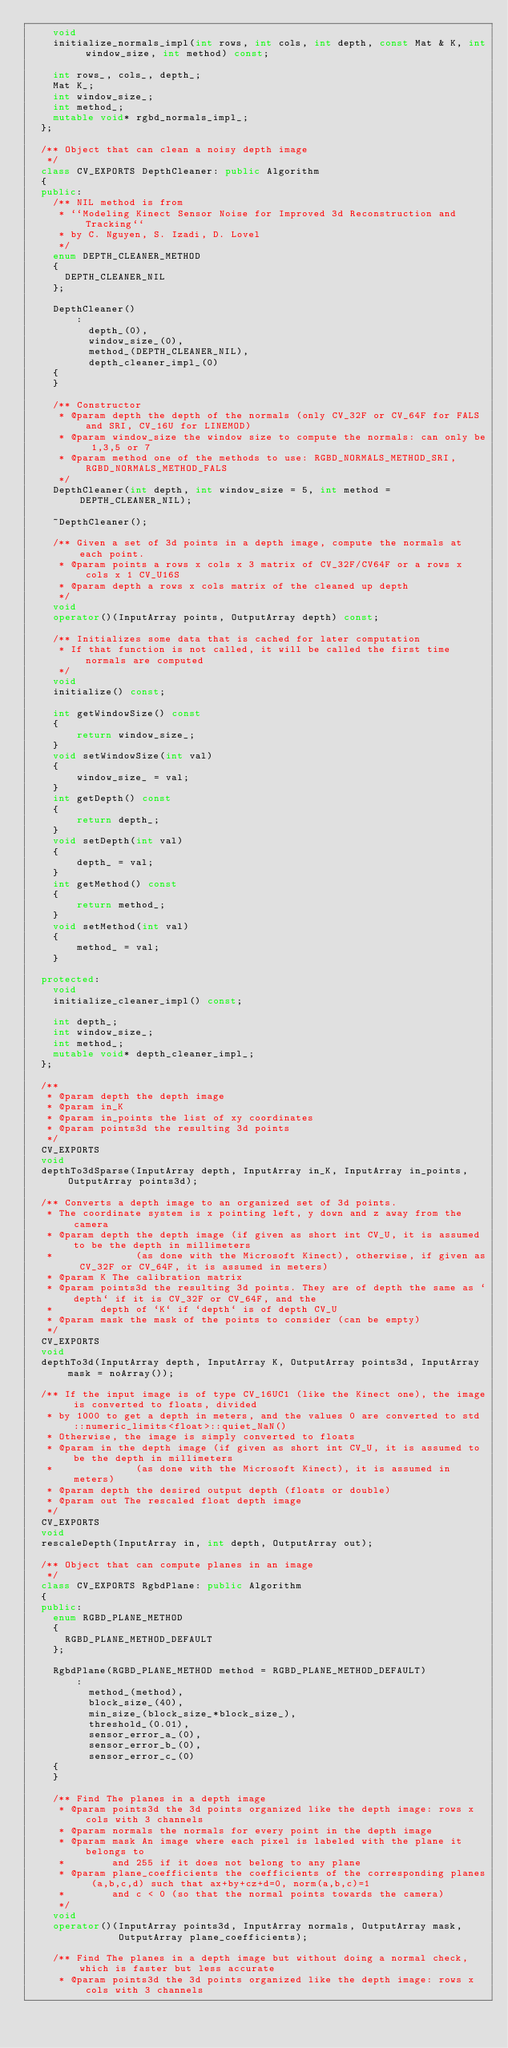Convert code to text. <code><loc_0><loc_0><loc_500><loc_500><_C++_>    void
    initialize_normals_impl(int rows, int cols, int depth, const Mat & K, int window_size, int method) const;

    int rows_, cols_, depth_;
    Mat K_;
    int window_size_;
    int method_;
    mutable void* rgbd_normals_impl_;
  };

  /** Object that can clean a noisy depth image
   */
  class CV_EXPORTS DepthCleaner: public Algorithm
  {
  public:
    /** NIL method is from
     * ``Modeling Kinect Sensor Noise for Improved 3d Reconstruction and Tracking``
     * by C. Nguyen, S. Izadi, D. Lovel
     */
    enum DEPTH_CLEANER_METHOD
    {
      DEPTH_CLEANER_NIL
    };

    DepthCleaner()
        :
          depth_(0),
          window_size_(0),
          method_(DEPTH_CLEANER_NIL),
          depth_cleaner_impl_(0)
    {
    }

    /** Constructor
     * @param depth the depth of the normals (only CV_32F or CV_64F for FALS and SRI, CV_16U for LINEMOD)
     * @param window_size the window size to compute the normals: can only be 1,3,5 or 7
     * @param method one of the methods to use: RGBD_NORMALS_METHOD_SRI, RGBD_NORMALS_METHOD_FALS
     */
    DepthCleaner(int depth, int window_size = 5, int method = DEPTH_CLEANER_NIL);

    ~DepthCleaner();

    /** Given a set of 3d points in a depth image, compute the normals at each point.
     * @param points a rows x cols x 3 matrix of CV_32F/CV64F or a rows x cols x 1 CV_U16S
     * @param depth a rows x cols matrix of the cleaned up depth
     */
    void
    operator()(InputArray points, OutputArray depth) const;

    /** Initializes some data that is cached for later computation
     * If that function is not called, it will be called the first time normals are computed
     */
    void
    initialize() const;

    int getWindowSize() const
    {
        return window_size_;
    }
    void setWindowSize(int val)
    {
        window_size_ = val;
    }
    int getDepth() const
    {
        return depth_;
    }
    void setDepth(int val)
    {
        depth_ = val;
    }
    int getMethod() const
    {
        return method_;
    }
    void setMethod(int val)
    {
        method_ = val;
    }

  protected:
    void
    initialize_cleaner_impl() const;

    int depth_;
    int window_size_;
    int method_;
    mutable void* depth_cleaner_impl_;
  };

  /**
   * @param depth the depth image
   * @param in_K
   * @param in_points the list of xy coordinates
   * @param points3d the resulting 3d points
   */
  CV_EXPORTS
  void
  depthTo3dSparse(InputArray depth, InputArray in_K, InputArray in_points, OutputArray points3d);

  /** Converts a depth image to an organized set of 3d points.
   * The coordinate system is x pointing left, y down and z away from the camera
   * @param depth the depth image (if given as short int CV_U, it is assumed to be the depth in millimeters
   *              (as done with the Microsoft Kinect), otherwise, if given as CV_32F or CV_64F, it is assumed in meters)
   * @param K The calibration matrix
   * @param points3d the resulting 3d points. They are of depth the same as `depth` if it is CV_32F or CV_64F, and the
   *        depth of `K` if `depth` is of depth CV_U
   * @param mask the mask of the points to consider (can be empty)
   */
  CV_EXPORTS
  void
  depthTo3d(InputArray depth, InputArray K, OutputArray points3d, InputArray mask = noArray());

  /** If the input image is of type CV_16UC1 (like the Kinect one), the image is converted to floats, divided
   * by 1000 to get a depth in meters, and the values 0 are converted to std::numeric_limits<float>::quiet_NaN()
   * Otherwise, the image is simply converted to floats
   * @param in the depth image (if given as short int CV_U, it is assumed to be the depth in millimeters
   *              (as done with the Microsoft Kinect), it is assumed in meters)
   * @param depth the desired output depth (floats or double)
   * @param out The rescaled float depth image
   */
  CV_EXPORTS
  void
  rescaleDepth(InputArray in, int depth, OutputArray out);

  /** Object that can compute planes in an image
   */
  class CV_EXPORTS RgbdPlane: public Algorithm
  {
  public:
    enum RGBD_PLANE_METHOD
    {
      RGBD_PLANE_METHOD_DEFAULT
    };

    RgbdPlane(RGBD_PLANE_METHOD method = RGBD_PLANE_METHOD_DEFAULT)
        :
          method_(method),
          block_size_(40),
          min_size_(block_size_*block_size_),
          threshold_(0.01),
          sensor_error_a_(0),
          sensor_error_b_(0),
          sensor_error_c_(0)
    {
    }

    /** Find The planes in a depth image
     * @param points3d the 3d points organized like the depth image: rows x cols with 3 channels
     * @param normals the normals for every point in the depth image
     * @param mask An image where each pixel is labeled with the plane it belongs to
     *        and 255 if it does not belong to any plane
     * @param plane_coefficients the coefficients of the corresponding planes (a,b,c,d) such that ax+by+cz+d=0, norm(a,b,c)=1
     *        and c < 0 (so that the normal points towards the camera)
     */
    void
    operator()(InputArray points3d, InputArray normals, OutputArray mask,
               OutputArray plane_coefficients);

    /** Find The planes in a depth image but without doing a normal check, which is faster but less accurate
     * @param points3d the 3d points organized like the depth image: rows x cols with 3 channels</code> 